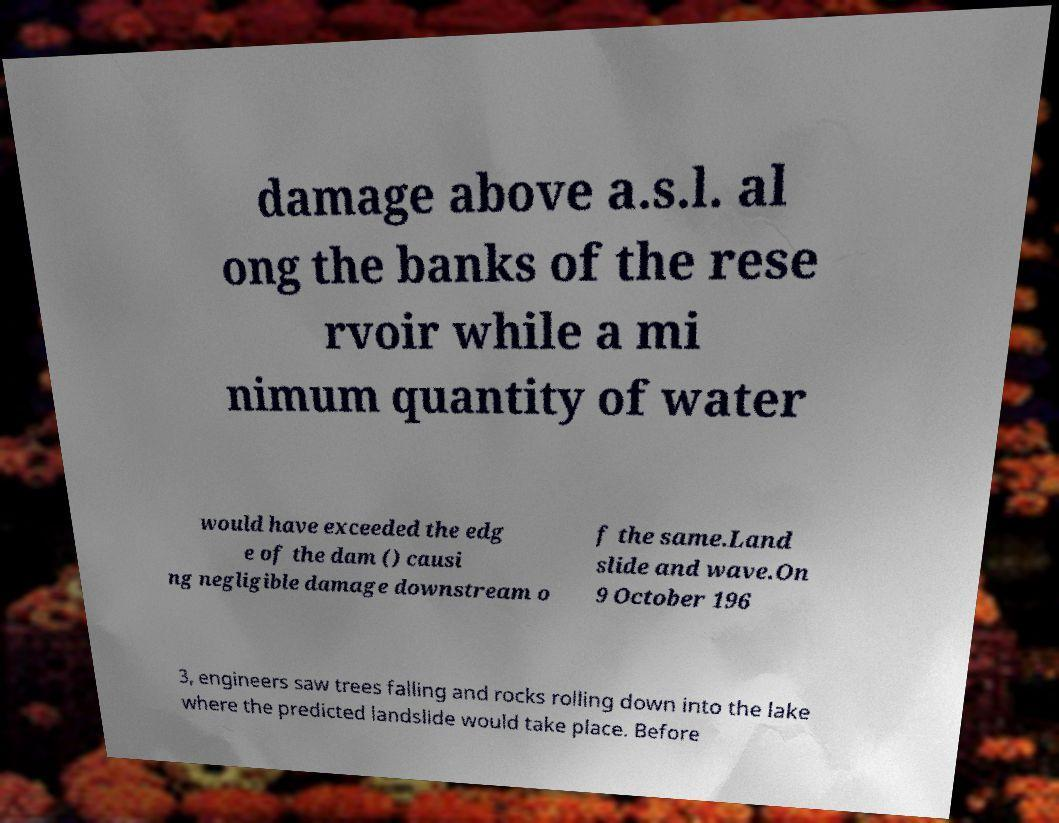I need the written content from this picture converted into text. Can you do that? damage above a.s.l. al ong the banks of the rese rvoir while a mi nimum quantity of water would have exceeded the edg e of the dam () causi ng negligible damage downstream o f the same.Land slide and wave.On 9 October 196 3, engineers saw trees falling and rocks rolling down into the lake where the predicted landslide would take place. Before 